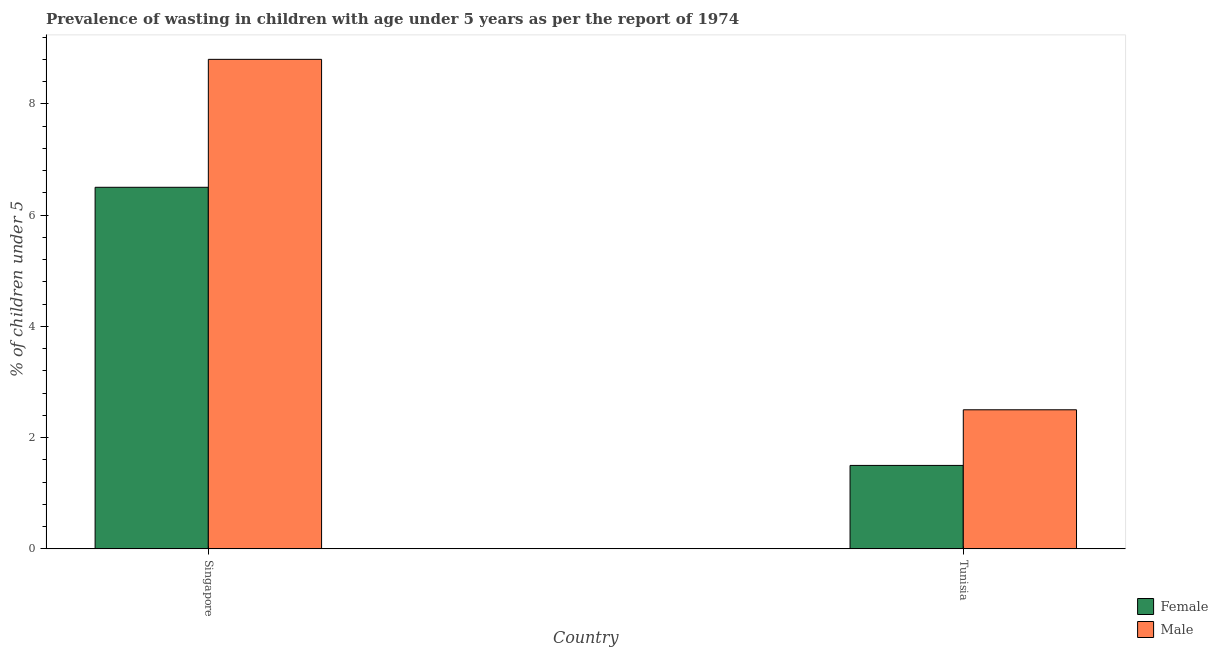How many groups of bars are there?
Make the answer very short. 2. Are the number of bars per tick equal to the number of legend labels?
Your answer should be compact. Yes. How many bars are there on the 1st tick from the left?
Provide a short and direct response. 2. How many bars are there on the 2nd tick from the right?
Keep it short and to the point. 2. What is the label of the 1st group of bars from the left?
Your response must be concise. Singapore. What is the percentage of undernourished female children in Tunisia?
Your answer should be compact. 1.5. In which country was the percentage of undernourished male children maximum?
Keep it short and to the point. Singapore. In which country was the percentage of undernourished male children minimum?
Give a very brief answer. Tunisia. What is the total percentage of undernourished male children in the graph?
Make the answer very short. 11.3. What is the difference between the percentage of undernourished female children in Tunisia and the percentage of undernourished male children in Singapore?
Provide a succinct answer. -7.3. What is the average percentage of undernourished male children per country?
Your answer should be compact. 5.65. What is the difference between the percentage of undernourished male children and percentage of undernourished female children in Singapore?
Offer a very short reply. 2.3. In how many countries, is the percentage of undernourished male children greater than 2.4 %?
Ensure brevity in your answer.  2. What is the ratio of the percentage of undernourished female children in Singapore to that in Tunisia?
Give a very brief answer. 4.33. Are all the bars in the graph horizontal?
Give a very brief answer. No. What is the difference between two consecutive major ticks on the Y-axis?
Your answer should be compact. 2. Are the values on the major ticks of Y-axis written in scientific E-notation?
Offer a very short reply. No. Does the graph contain any zero values?
Give a very brief answer. No. Does the graph contain grids?
Give a very brief answer. No. Where does the legend appear in the graph?
Your response must be concise. Bottom right. How are the legend labels stacked?
Make the answer very short. Vertical. What is the title of the graph?
Offer a very short reply. Prevalence of wasting in children with age under 5 years as per the report of 1974. Does "All education staff compensation" appear as one of the legend labels in the graph?
Your response must be concise. No. What is the label or title of the Y-axis?
Your answer should be very brief.  % of children under 5. What is the  % of children under 5 of Female in Singapore?
Your answer should be compact. 6.5. What is the  % of children under 5 of Male in Singapore?
Ensure brevity in your answer.  8.8. What is the  % of children under 5 of Female in Tunisia?
Ensure brevity in your answer.  1.5. Across all countries, what is the maximum  % of children under 5 of Female?
Ensure brevity in your answer.  6.5. Across all countries, what is the maximum  % of children under 5 of Male?
Provide a succinct answer. 8.8. What is the total  % of children under 5 in Female in the graph?
Ensure brevity in your answer.  8. What is the difference between the  % of children under 5 in Male in Singapore and that in Tunisia?
Provide a succinct answer. 6.3. What is the difference between the  % of children under 5 of Female in Singapore and the  % of children under 5 of Male in Tunisia?
Keep it short and to the point. 4. What is the average  % of children under 5 of Male per country?
Offer a very short reply. 5.65. What is the difference between the  % of children under 5 in Female and  % of children under 5 in Male in Tunisia?
Ensure brevity in your answer.  -1. What is the ratio of the  % of children under 5 in Female in Singapore to that in Tunisia?
Offer a very short reply. 4.33. What is the ratio of the  % of children under 5 in Male in Singapore to that in Tunisia?
Provide a short and direct response. 3.52. What is the difference between the highest and the second highest  % of children under 5 in Male?
Keep it short and to the point. 6.3. What is the difference between the highest and the lowest  % of children under 5 in Female?
Your answer should be very brief. 5. 